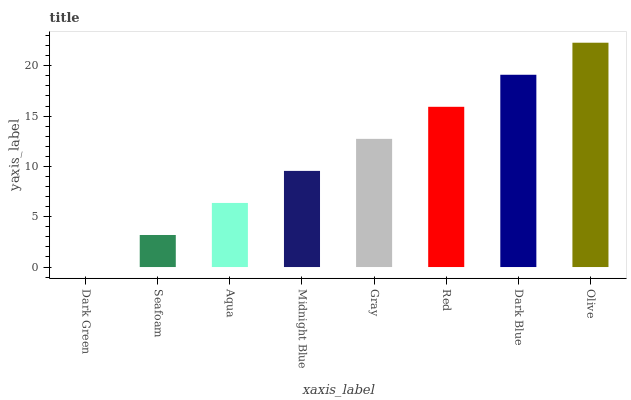Is Dark Green the minimum?
Answer yes or no. Yes. Is Olive the maximum?
Answer yes or no. Yes. Is Seafoam the minimum?
Answer yes or no. No. Is Seafoam the maximum?
Answer yes or no. No. Is Seafoam greater than Dark Green?
Answer yes or no. Yes. Is Dark Green less than Seafoam?
Answer yes or no. Yes. Is Dark Green greater than Seafoam?
Answer yes or no. No. Is Seafoam less than Dark Green?
Answer yes or no. No. Is Gray the high median?
Answer yes or no. Yes. Is Midnight Blue the low median?
Answer yes or no. Yes. Is Aqua the high median?
Answer yes or no. No. Is Dark Green the low median?
Answer yes or no. No. 